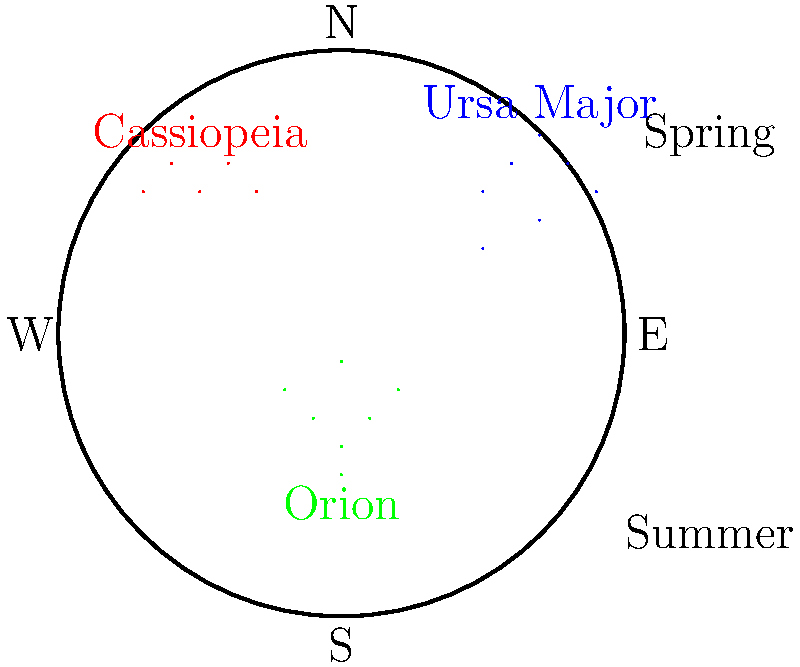Which of the constellations shown in the diagram is typically visible in the night sky over Toronto during the summer months? To answer this question, we need to consider the following steps:

1. Understand the orientation of the night sky:
   - The diagram shows a view of the night sky with cardinal directions marked.
   - North is at the top, South at the bottom, East to the right, and West to the left.

2. Identify the constellations in the diagram:
   - Ursa Major (blue) is shown in the upper right quadrant.
   - Cassiopeia (red) is shown in the upper left quadrant.
   - Orion (green) is shown in the lower central area.

3. Consider the seasonal visibility of constellations:
   - The diagram indicates that it represents the spring and summer sky.
   - Constellations near the celestial pole (close to the North direction) are visible year-round in the Northern Hemisphere.
   - Constellations lower in the sky have seasonal visibility.

4. Analyze each constellation's position:
   - Ursa Major is high in the northern sky, making it visible year-round from Toronto.
   - Cassiopeia is also near the northern sky, visible year-round but lower in the summer.
   - Orion is low in the southern sky, typically visible in winter and not in summer.

5. Consider Toronto's latitude:
   - Toronto is in the Northern Hemisphere at approximately 43.7° N latitude.
   - This means circumpolar constellations (those near the celestial pole) are always visible.

Based on this analysis, we can conclude that Ursa Major is the constellation among those shown that would be typically visible in the night sky over Toronto during the summer months.
Answer: Ursa Major 